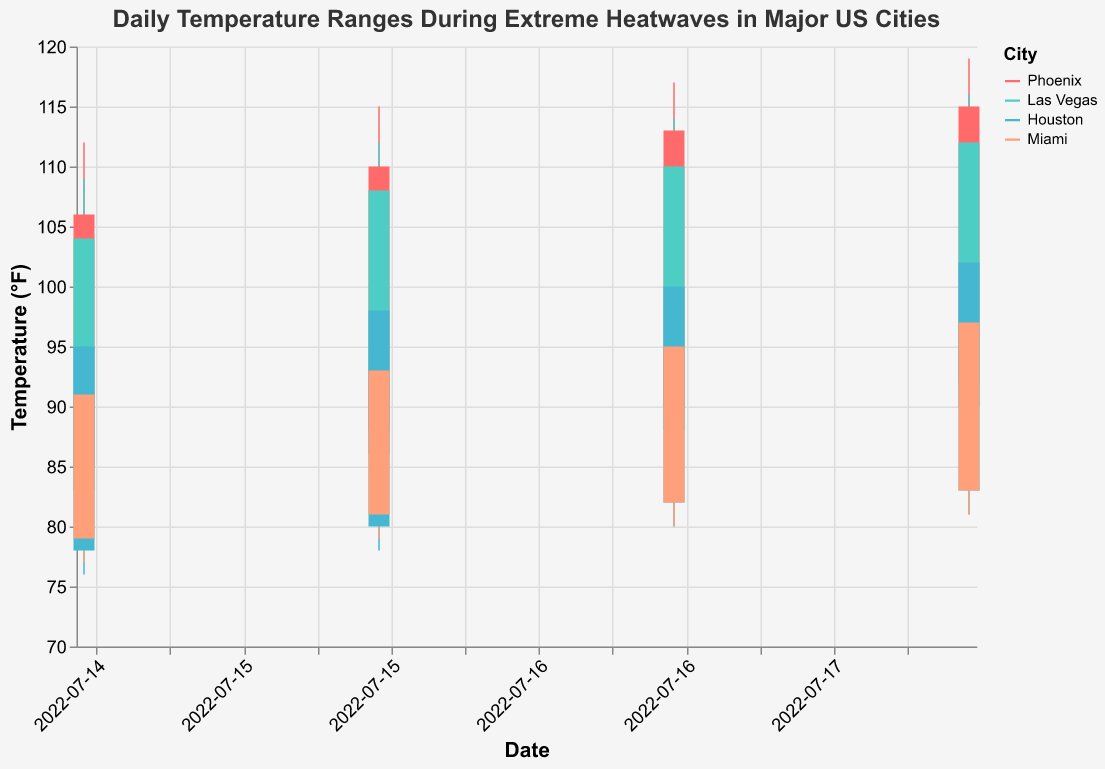What is the highest recorded temperature on July 18, 2022? To find the highest recorded temperature, look at the highest value for July 18, 2022 across all cities. Phoenix has the highest temperature of 119°F.
Answer: 119°F Which city had the lowest opening temperature on July 15, 2022? To determine this, check the "Open" temperatures for all cities on July 15, 2022. Houston had the lowest opening temperature of 78°F.
Answer: Houston What is the temperature range (High - Low) for Miami on July 17, 2022? The high temperature for Miami on July 17, 2022 is 99°F and the low is 80°F. Subtract the low from the high to get the temperature range: 99°F - 80°F = 19°F.
Answer: 19°F Compare the closing temperatures on July 16, 2022 for Phoenix and Las Vegas. Which city was hotter? The closing temperatures on July 16, 2022 for Phoenix and Las Vegas are 110°F and 108°F respectively. Phoenix was hotter.
Answer: Phoenix What was the largest increase in high temperature observed between consecutive days for any city? Calculate the increase in high temperature for consecutive days for each city. The largest increase is observed in Phoenix between July 15 (112°F) and July 16 (115°F), which is 3°F.
Answer: 3°F Which city's temperature remained consistently below 110°F during the period shown? To determine this, check the high temperatures for each city over the given dates. Houston's high temperatures remained below 110°F throughout the period.
Answer: Houston What is the average closing temperature for Phoenix during the 4-day period? Add up the closing temperatures for Phoenix over the 4 days (106°F + 110°F + 113°F + 115°F) and divide by 4. The calculation is (106 + 110 + 113 + 115) / 4 = 111°F.
Answer: 111°F How did the open and close temperatures differ for Las Vegas on July 17, 2022? Subtract the open temperature from the close temperature for Las Vegas on July 17, 2022. The open temperature is 88°F and the close is 110°F. The difference is 110 - 88 = 22°F.
Answer: 22°F 